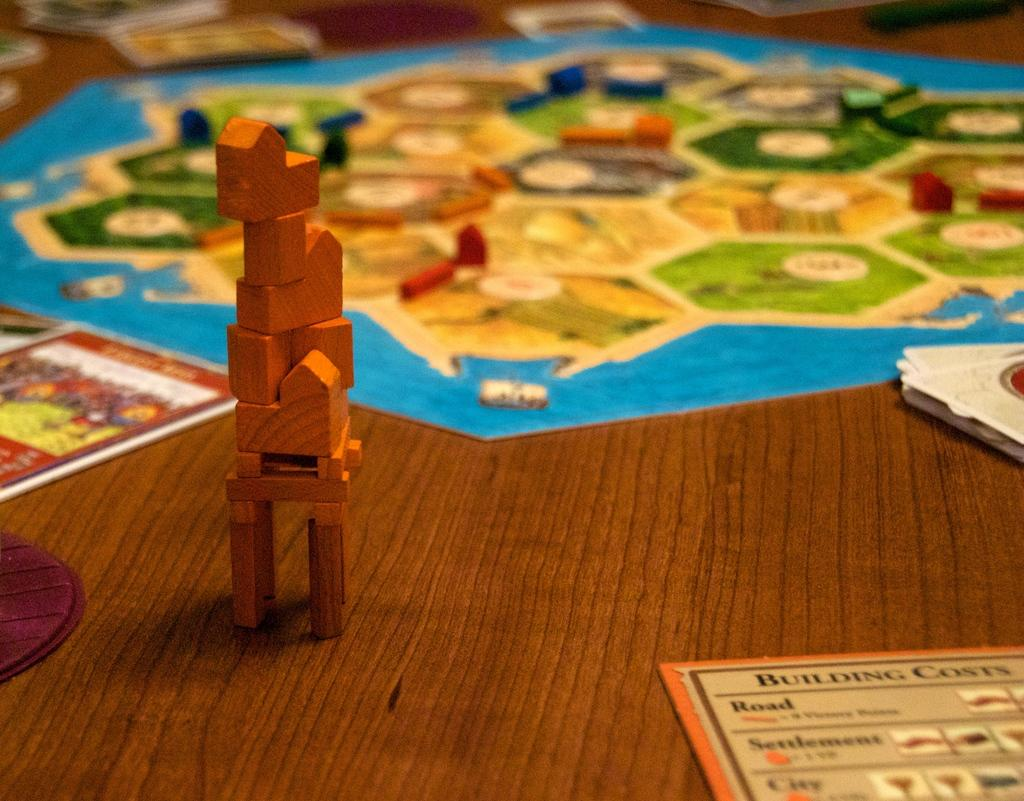What type of objects can be seen on the right side of the image? There are wooden building blocks on the right side of the image. What other items are present in the image? There are papers and a paper game play in the image. What material is the surface in the image made of? The surface in the image is made of wood. Can you describe the background of the image? The background of the image is blurred. How many snakes are crawling on the wooden surface in the image? There are no snakes present in the image; it only features wooden building blocks, papers, and a paper game play on a wooden surface. What is the name of the person who created the paper game play in the image? The name of the person who created the paper game play is not mentioned or visible in the image. 